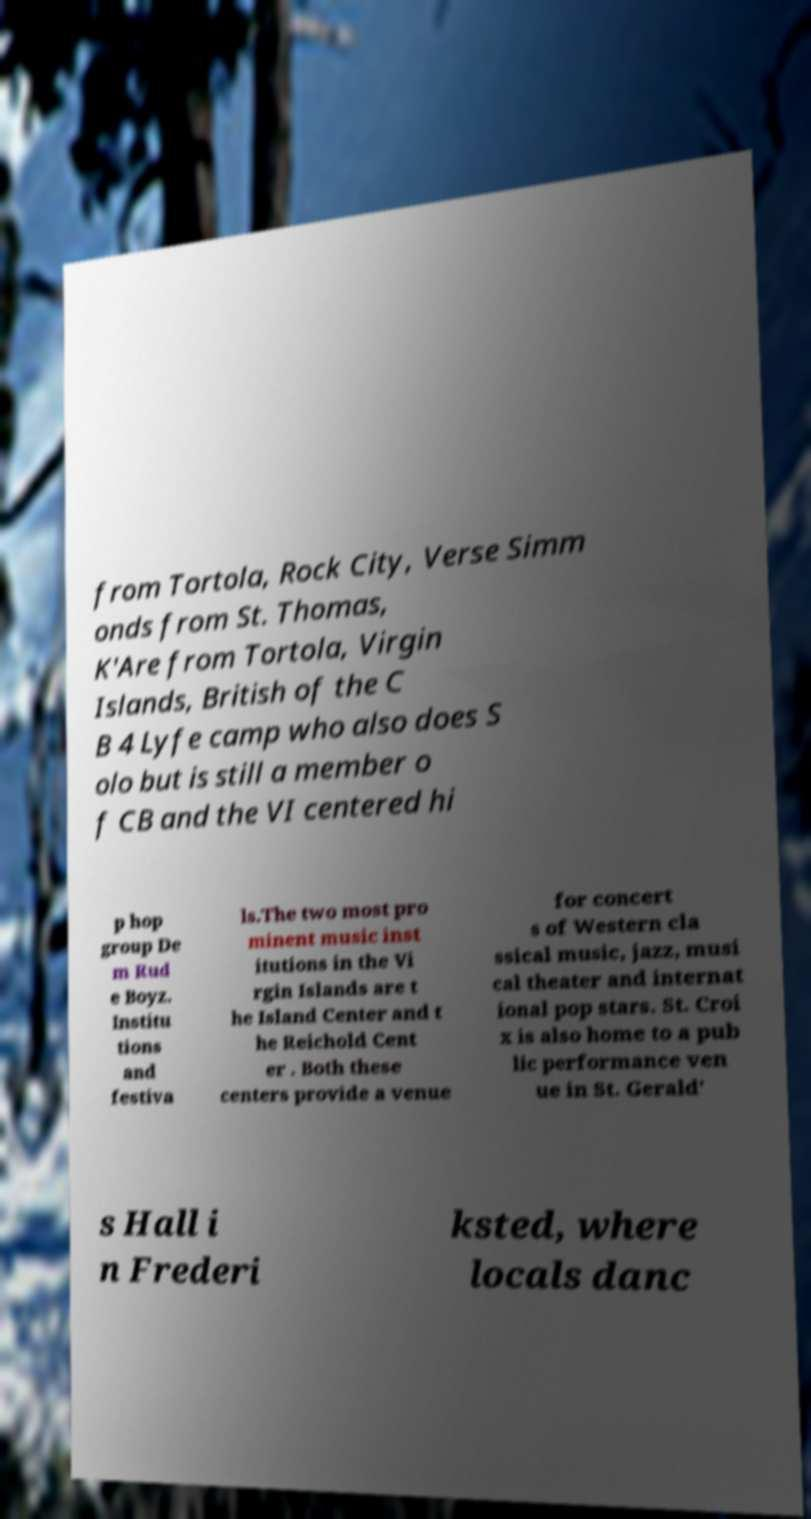Please read and relay the text visible in this image. What does it say? from Tortola, Rock City, Verse Simm onds from St. Thomas, K'Are from Tortola, Virgin Islands, British of the C B 4 Lyfe camp who also does S olo but is still a member o f CB and the VI centered hi p hop group De m Rud e Boyz. Institu tions and festiva ls.The two most pro minent music inst itutions in the Vi rgin Islands are t he Island Center and t he Reichold Cent er . Both these centers provide a venue for concert s of Western cla ssical music, jazz, musi cal theater and internat ional pop stars. St. Croi x is also home to a pub lic performance ven ue in St. Gerald' s Hall i n Frederi ksted, where locals danc 